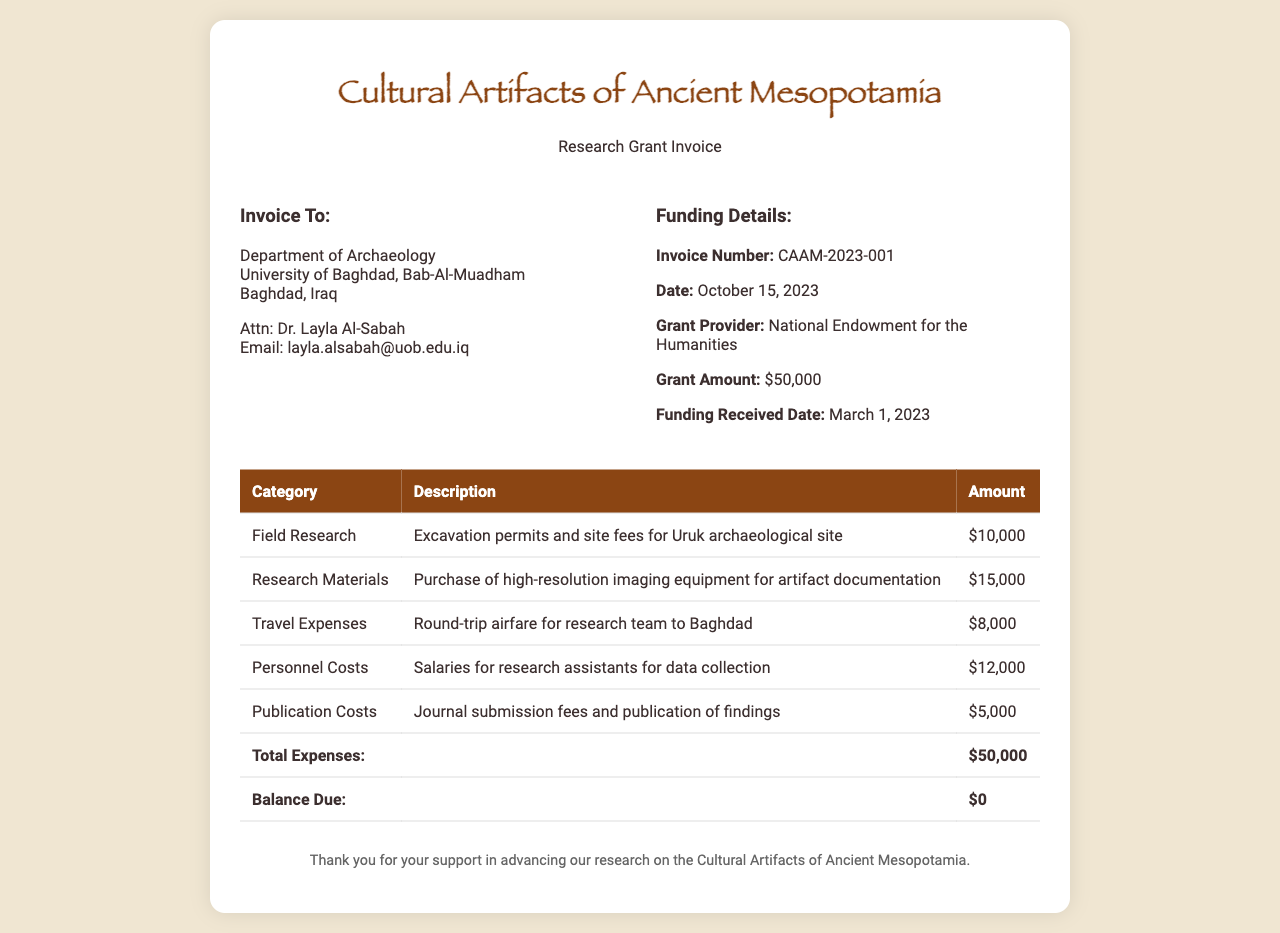What is the total grant amount? The total grant amount is indicated as the total funding provided for the project in the invoice.
Answer: $50,000 Who is the invoice addressed to? The recipient details in the document specify the address and name of the individual or organization that the invoice is directed towards.
Answer: Department of Archaeology What is the date of the invoice? The invoice date is mentioned in the funding details section, representing when the invoice was issued.
Answer: October 15, 2023 What amount was spent on research materials? The amount for research materials is given in the expenses section, specifying the costs related to those materials.
Answer: $15,000 What was the expenditure for publication costs? The document lists publication costs as one of the categories of expenses, indicating the amount spent for it.
Answer: $5,000 How much was allocated for travel expenses? The travel expenses section indicates the costs incurred for travel, reflecting a specific category in the expense table.
Answer: $8,000 When was the funding received? The funding received date is noted in the details section, marking when the grant was made available for the project.
Answer: March 1, 2023 What is the balance due? The total expenses and the calculations show the balance due at the end of the invoice, indicating if there are any remaining payments.
Answer: $0 What is the purpose of this invoice? The title and header of the document clarify the purpose of the invoice related to specific research efforts.
Answer: Research Grant Invoice 